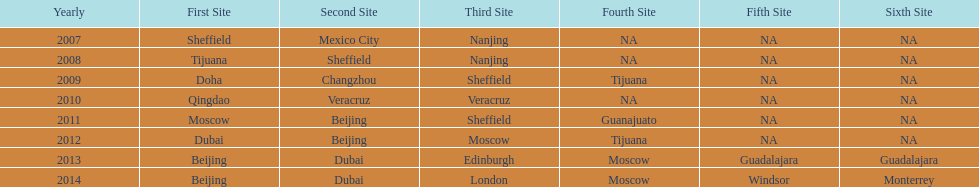What year had the same second event venue as the one in 2011? 2012. Parse the table in full. {'header': ['Yearly', 'First Site', 'Second Site', 'Third Site', 'Fourth Site', 'Fifth Site', 'Sixth Site'], 'rows': [['2007', 'Sheffield', 'Mexico City', 'Nanjing', 'NA', 'NA', 'NA'], ['2008', 'Tijuana', 'Sheffield', 'Nanjing', 'NA', 'NA', 'NA'], ['2009', 'Doha', 'Changzhou', 'Sheffield', 'Tijuana', 'NA', 'NA'], ['2010', 'Qingdao', 'Veracruz', 'Veracruz', 'NA', 'NA', 'NA'], ['2011', 'Moscow', 'Beijing', 'Sheffield', 'Guanajuato', 'NA', 'NA'], ['2012', 'Dubai', 'Beijing', 'Moscow', 'Tijuana', 'NA', 'NA'], ['2013', 'Beijing', 'Dubai', 'Edinburgh', 'Moscow', 'Guadalajara', 'Guadalajara'], ['2014', 'Beijing', 'Dubai', 'London', 'Moscow', 'Windsor', 'Monterrey']]} 